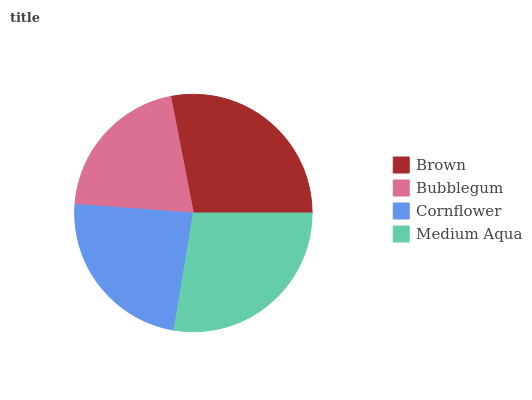Is Bubblegum the minimum?
Answer yes or no. Yes. Is Brown the maximum?
Answer yes or no. Yes. Is Cornflower the minimum?
Answer yes or no. No. Is Cornflower the maximum?
Answer yes or no. No. Is Cornflower greater than Bubblegum?
Answer yes or no. Yes. Is Bubblegum less than Cornflower?
Answer yes or no. Yes. Is Bubblegum greater than Cornflower?
Answer yes or no. No. Is Cornflower less than Bubblegum?
Answer yes or no. No. Is Medium Aqua the high median?
Answer yes or no. Yes. Is Cornflower the low median?
Answer yes or no. Yes. Is Cornflower the high median?
Answer yes or no. No. Is Medium Aqua the low median?
Answer yes or no. No. 